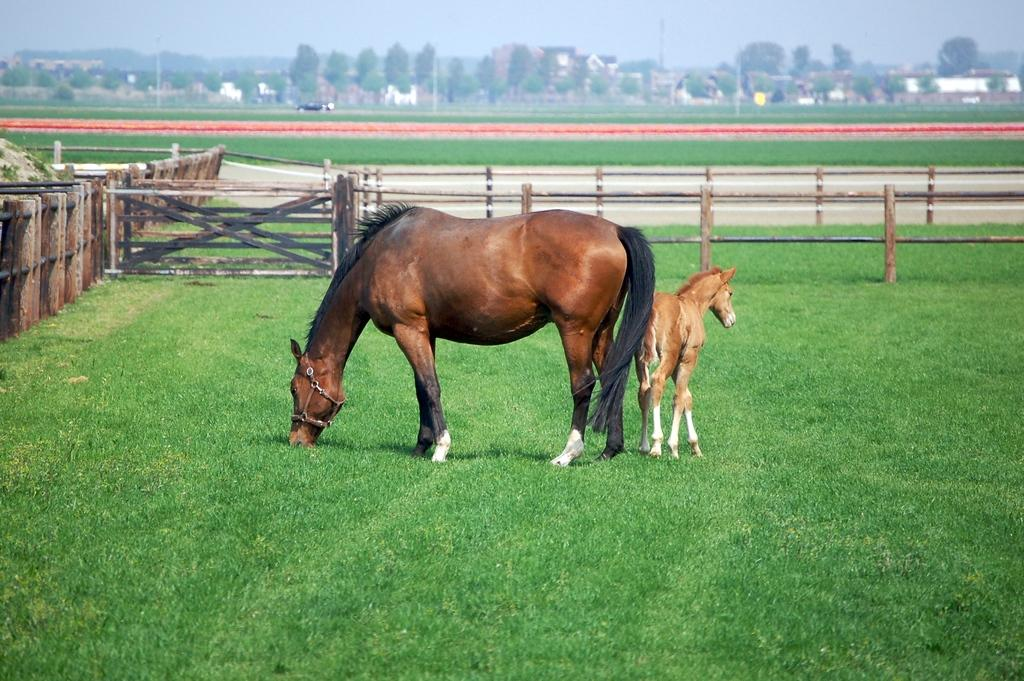What type of animal can be seen in the image? There is a horse in the image. Can you describe the horse's companion? There is a baby horse in the image. What is the surface that the horse and baby horse are standing on? They are on a grass surface. What encloses the area where the horse and baby horse are located? They are inside a wooden fence. What can be seen on the other side of the fence? There is grass, trees, and buildings visible on the other side of the fence. What type of fireman is present in the image? There is no fireman present in the image; it features a horse and baby horse in a grassy area surrounded by a wooden fence. 